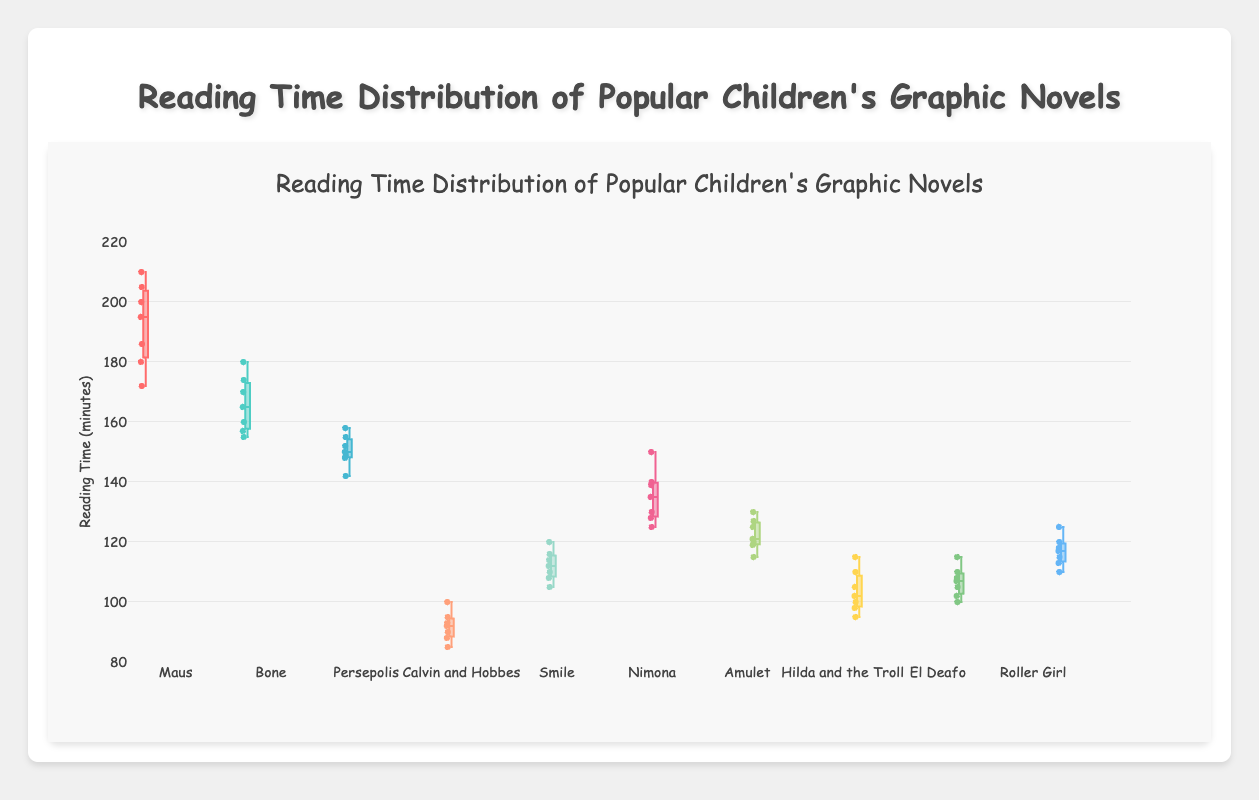What is the title of the box plot? The title is displayed at the top of the figure. It gives a concise description of what the plot represents.
Answer: Reading Time Distribution of Popular Children's Graphic Novels What is the minimum reading time recorded for "Calvin and Hobbes"? The minimum value is represented by the lower whisker of the box plot for "Calvin and Hobbes".
Answer: 85 minutes Which graphic novel has the widest interquartile range (IQR) in reading time? To determine this, compare the lengths of the boxes (the distance between the first quartile (Q1) and the third quartile (Q3)) for each graphic novel.
Answer: Maus Which graphic novel has the highest median reading time? The median is represented by the line inside the box for each novel. The highest median is the one whose line is positioned highest on the Y-axis.
Answer: Maus Describe the spread of reading times for "Bone". Look at the positions of the minimum, first quartile (Q1), median, third quartile (Q3), and maximum whisker for "Bone". The spread is relatively uniform with some slight skewness.
Answer: The reading times for "Bone" range from 155 to 180 minutes with a median of about 165 minutes Compare the reading times of "El Deafo" and "Roller Girl". Which has more variability? Variability is indicated by the length of the interquartile range (IQR) and the spread of the whiskers. A longer IQR and wider spread show more variability.
Answer: El Deafo Which graphic novel has the smallest range in reading time? The range is found by subtracting the minimum value from the maximum value for each novel. The novel with the smallest difference has the smallest range.
Answer: Persepolis What is the median reading time for "Smile"? The median is the line inside the box for "Smile". Locate this line on the Y-axis to find its value.
Answer: 112 minutes What conclusions can you draw about the reading times for “Hilda and the Troll”? Analyze the position of the quartiles, median, and range. A concise conclusion can be made based on how these elements are spread.
Answer: The reading times for “Hilda and the Troll” are moderately spread with a median of about 102 minutes, indicating consistent reading times around this value Identify the graphic novel with the most outliers and explain how you determined this. Outliers are individual points that fall outside the whiskers. Count the outliers for each graphic novel to identify the one with the most.
Answer: Maus with three outliers 